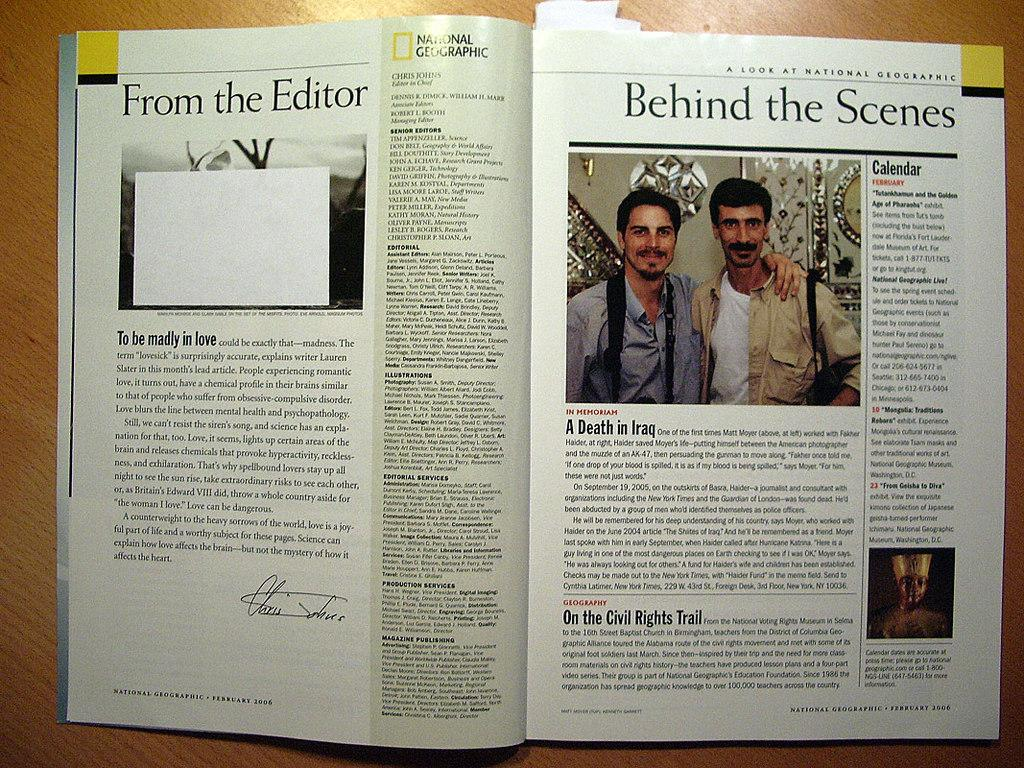<image>
Present a compact description of the photo's key features. A magazine is open showing two guys pictured with the title Behind the Scenes. 